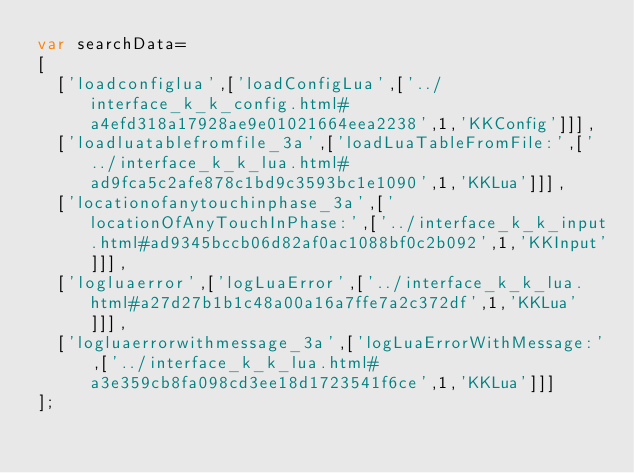Convert code to text. <code><loc_0><loc_0><loc_500><loc_500><_JavaScript_>var searchData=
[
  ['loadconfiglua',['loadConfigLua',['../interface_k_k_config.html#a4efd318a17928ae9e01021664eea2238',1,'KKConfig']]],
  ['loadluatablefromfile_3a',['loadLuaTableFromFile:',['../interface_k_k_lua.html#ad9fca5c2afe878c1bd9c3593bc1e1090',1,'KKLua']]],
  ['locationofanytouchinphase_3a',['locationOfAnyTouchInPhase:',['../interface_k_k_input.html#ad9345bccb06d82af0ac1088bf0c2b092',1,'KKInput']]],
  ['logluaerror',['logLuaError',['../interface_k_k_lua.html#a27d27b1b1c48a00a16a7ffe7a2c372df',1,'KKLua']]],
  ['logluaerrorwithmessage_3a',['logLuaErrorWithMessage:',['../interface_k_k_lua.html#a3e359cb8fa098cd3ee18d1723541f6ce',1,'KKLua']]]
];
</code> 